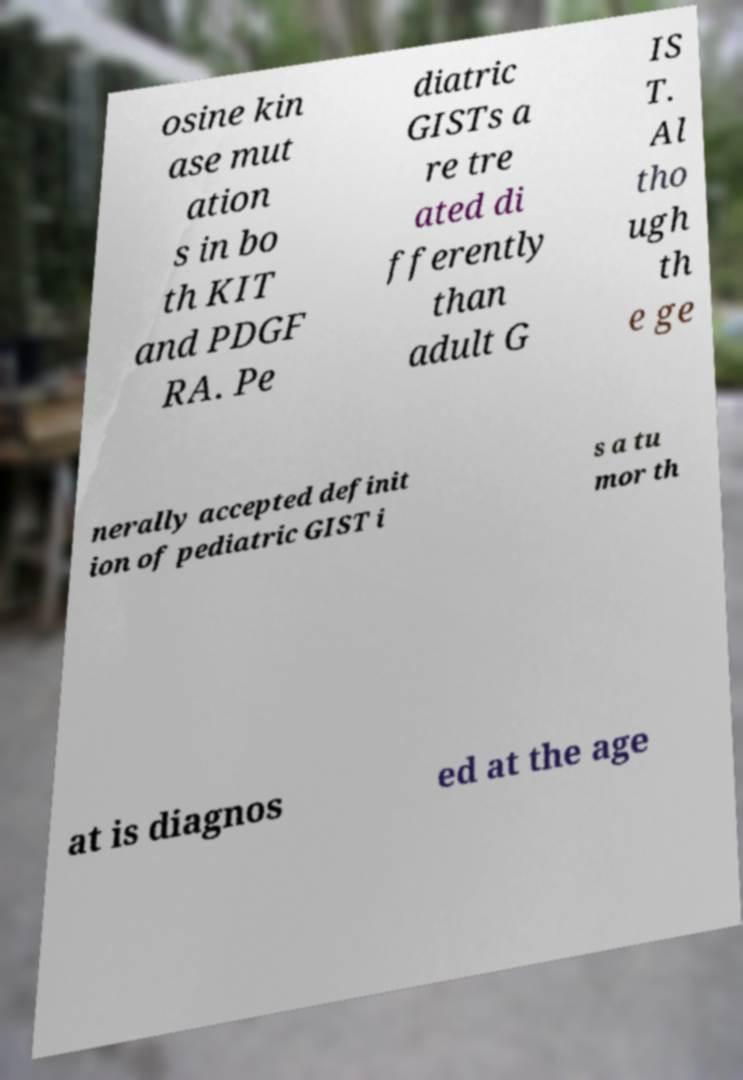What messages or text are displayed in this image? I need them in a readable, typed format. osine kin ase mut ation s in bo th KIT and PDGF RA. Pe diatric GISTs a re tre ated di fferently than adult G IS T. Al tho ugh th e ge nerally accepted definit ion of pediatric GIST i s a tu mor th at is diagnos ed at the age 